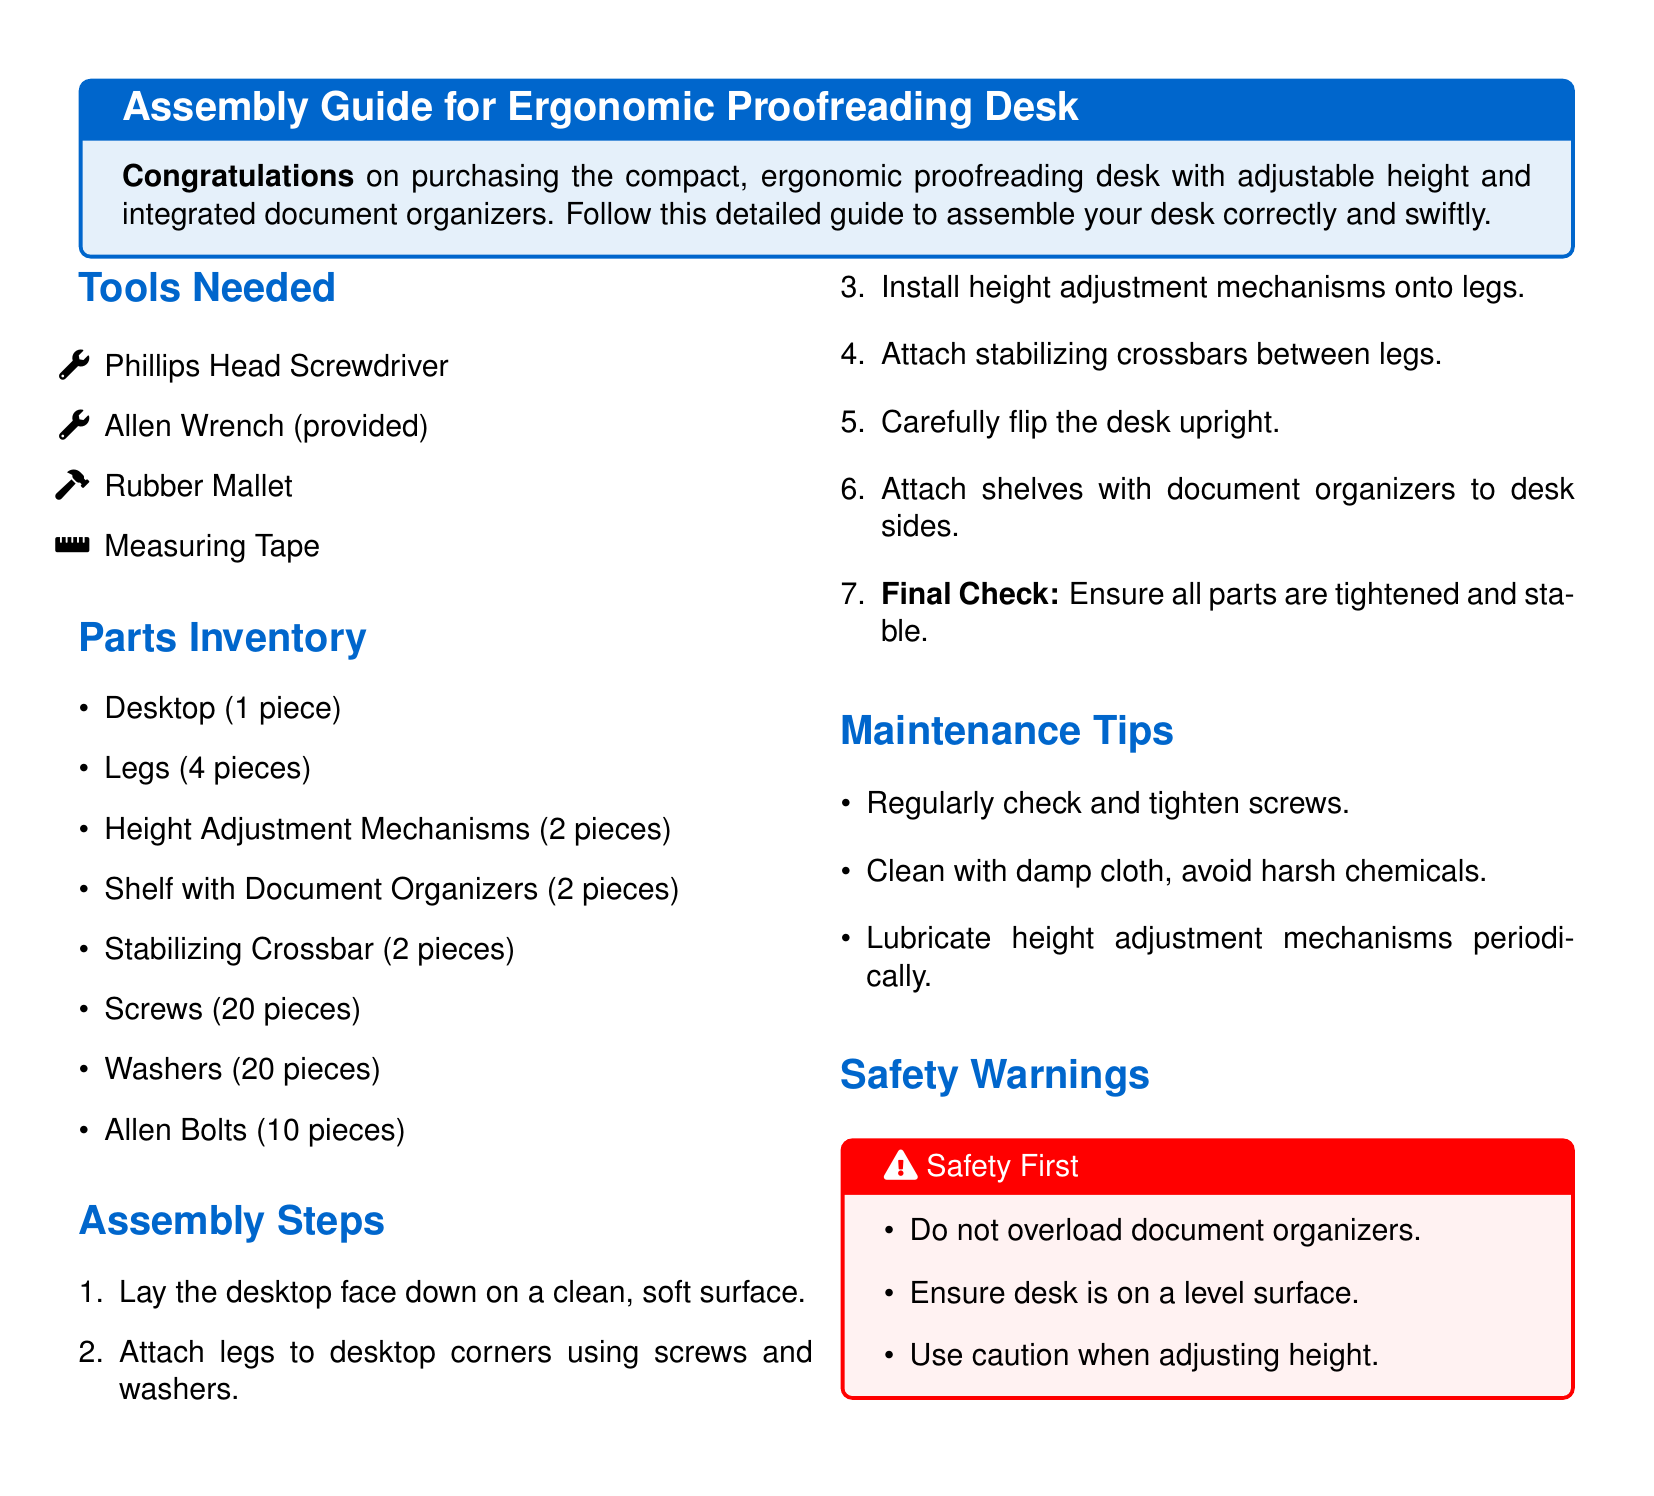What tools are needed? The tools needed are provided in the "Tools Needed" section of the document.
Answer: Phillips Head Screwdriver, Allen Wrench, Rubber Mallet, Measuring Tape How many legs are there? The number of legs is listed in the "Parts Inventory" section.
Answer: 4 pieces What is the first assembly step? The first step is described in the "Assembly Steps" section of the document.
Answer: Lay the desktop face down on a clean, soft surface How many screws are included? The total number of screws is found in the "Parts Inventory" section.
Answer: 20 pieces What should you do for maintenance? Maintenance tips are outlined in the "Maintenance Tips" section.
Answer: Regularly check and tighten screws What is a safety warning about the desk? A safety warning is given in the "Safety Warnings" section.
Answer: Do not overload document organizers How many height adjustment mechanisms are there? The number of height adjustment mechanisms is listed under the "Parts Inventory" section.
Answer: 2 pieces What should be used to clean the desk? The cleaning method is mentioned in the "Maintenance Tips" section.
Answer: Damp cloth, avoid harsh chemicals 